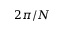<formula> <loc_0><loc_0><loc_500><loc_500>2 \pi / N</formula> 